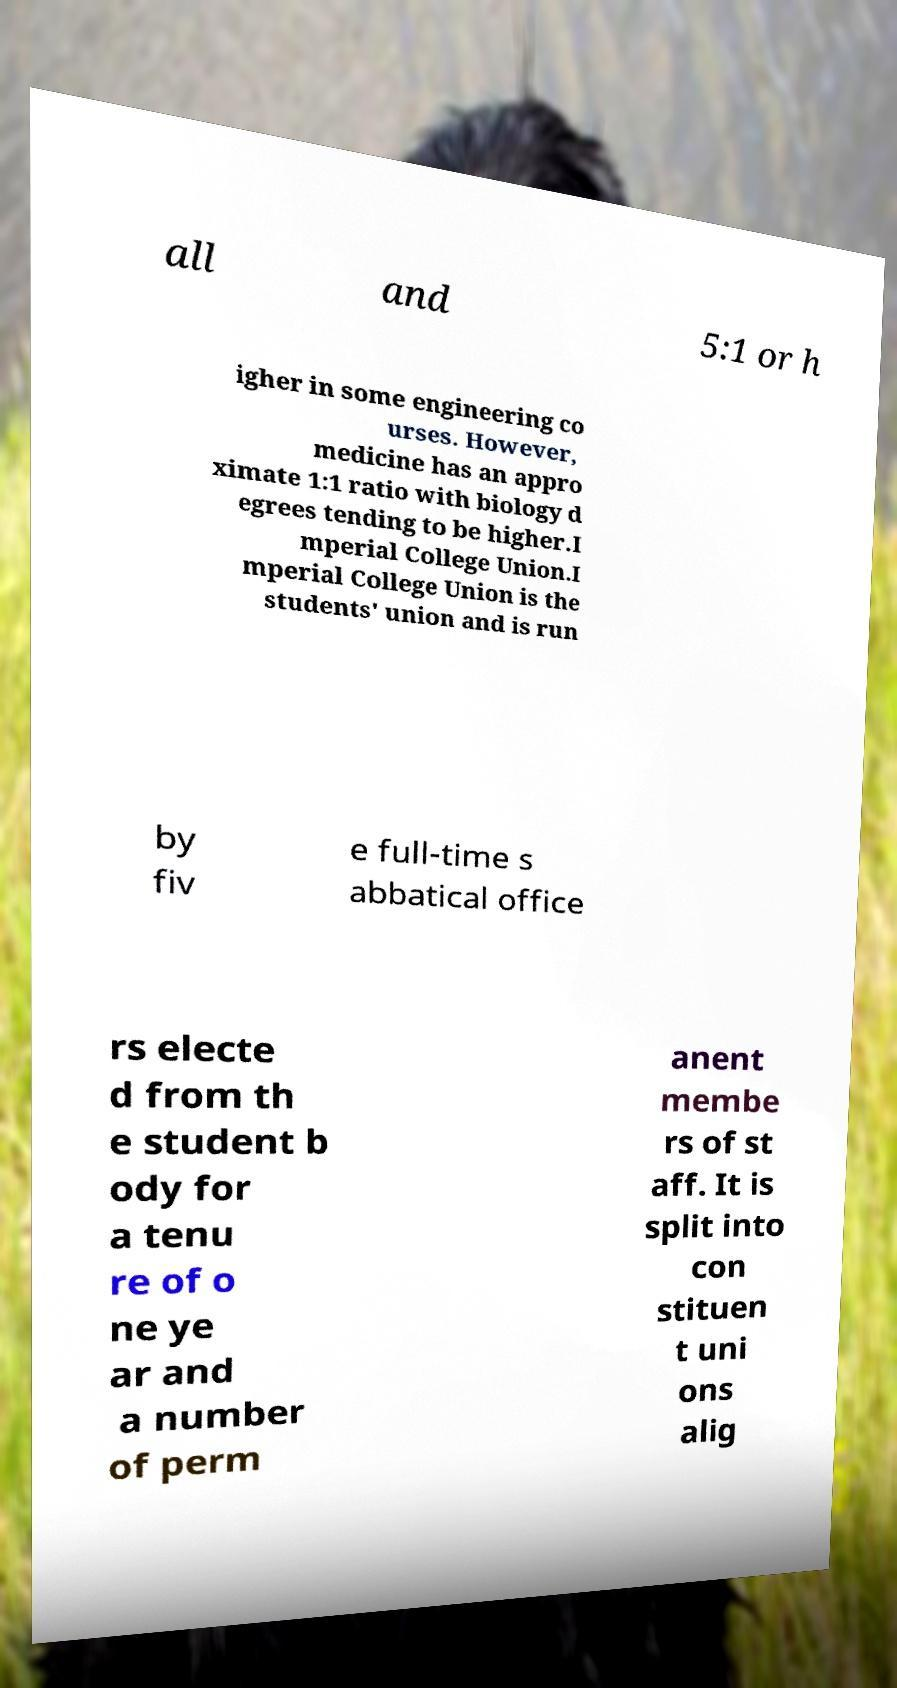Can you read and provide the text displayed in the image?This photo seems to have some interesting text. Can you extract and type it out for me? all and 5:1 or h igher in some engineering co urses. However, medicine has an appro ximate 1:1 ratio with biology d egrees tending to be higher.I mperial College Union.I mperial College Union is the students' union and is run by fiv e full-time s abbatical office rs electe d from th e student b ody for a tenu re of o ne ye ar and a number of perm anent membe rs of st aff. It is split into con stituen t uni ons alig 